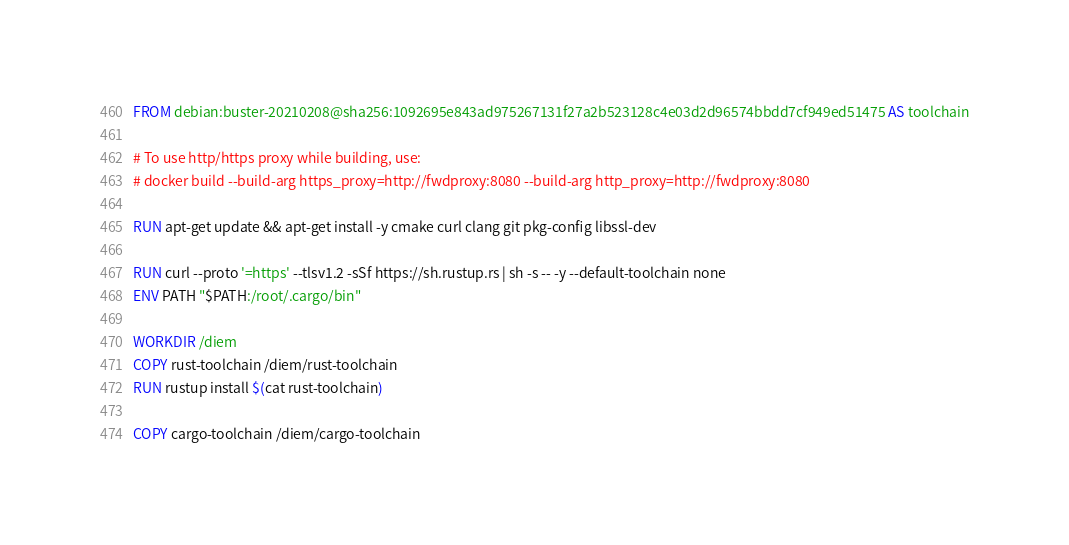<code> <loc_0><loc_0><loc_500><loc_500><_Dockerfile_>FROM debian:buster-20210208@sha256:1092695e843ad975267131f27a2b523128c4e03d2d96574bbdd7cf949ed51475 AS toolchain

# To use http/https proxy while building, use:
# docker build --build-arg https_proxy=http://fwdproxy:8080 --build-arg http_proxy=http://fwdproxy:8080

RUN apt-get update && apt-get install -y cmake curl clang git pkg-config libssl-dev

RUN curl --proto '=https' --tlsv1.2 -sSf https://sh.rustup.rs | sh -s -- -y --default-toolchain none
ENV PATH "$PATH:/root/.cargo/bin"

WORKDIR /diem
COPY rust-toolchain /diem/rust-toolchain
RUN rustup install $(cat rust-toolchain)

COPY cargo-toolchain /diem/cargo-toolchain</code> 